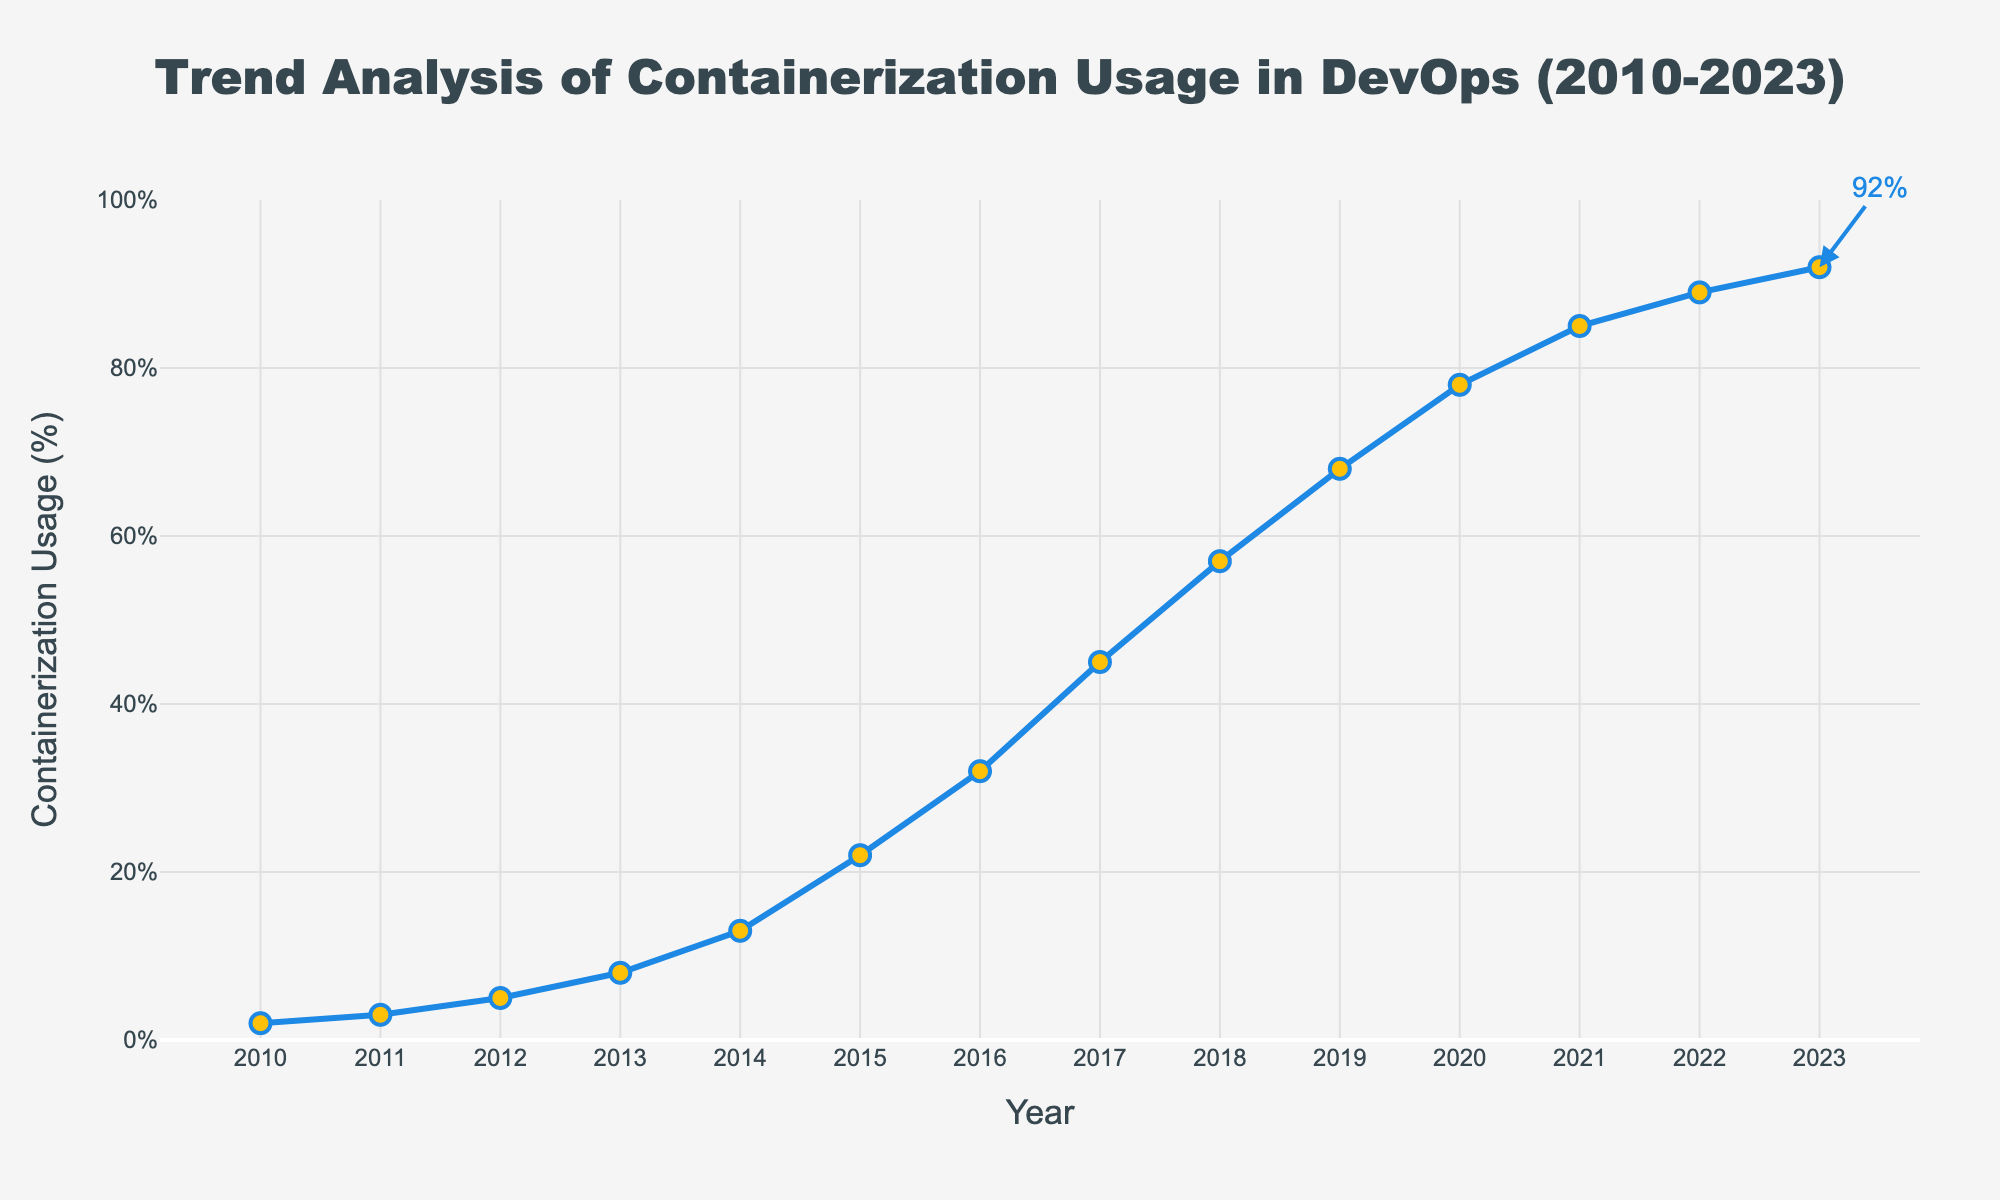What's the overall trend in containerization usage from 2010 to 2023? The trend in containerization usage shows a consistent increase over the years from 2010 to 2023. Starting from 2% in 2010, it climbs steadily each year, reaching 92% in 2023. This indicates a high adoption rate over time.
Answer: Increasing Which year shows the highest jump in containerization usage percentage? By comparing the annual increments, the highest jump in percentage occurs between 2014 and 2015, where usage increased from 13% to 22%, making it a 9% increase.
Answer: 2015 What's the average containerization usage from 2010 to 2023? To find the average, sum the containerization usage percentages for each year and divide by the number of years: (2 + 3 + 5 + 8 + 13 + 22 + 32 + 45 + 57 + 68 + 78 + 85 + 89 + 92) / 14 = 45.64.
Answer: 45.64% How much did containerization usage increase from 2010 to 2023? Subtract the percentage in 2010 from the percentage in 2023: 92% - 2% = 90%.
Answer: 90% What is the percentage increase in containerization usage from 2019 to 2021? Subtract the percentage in 2019 from the percentage in 2021 and divide by the 2019 percentage: (85 - 68) / 68 * 100 ≈ 25%.
Answer: 25% Which two consecutive years had the highest and lowest increase in containerization usage? To find the highest and lowest increases, calculate the differences between consecutive years. The highest increase is between 2014 and 2015 (22% - 13% = 9%), and the lowest is between 2022 and 2023 (92% - 89% = 3%).
Answer: 2014 and 2015, 2022 and 2023 What is the median value of containerization usage from 2010 and 2023? Sorting the percentages: 2, 3, 5, 8, 13, 22, 32, 45, 57, 68, 78, 85, 89, 92. The median is the average of the 7th and 8th values: (32 + 45) / 2 = 38.5%.
Answer: 38.5% Was the rate of increase in containerization usage higher before or after 2017? Calculate the difference before 2017 (32% - 2% = 30%) and after 2017 (92% - 32% = 60%). The increase after 2017 is higher.
Answer: After 2017 In which year does containerization usage surpass 50%? By inspecting the usage percentages year by year, containerization usage first exceeds 50% in 2018, where it reaches 57%.
Answer: 2018 